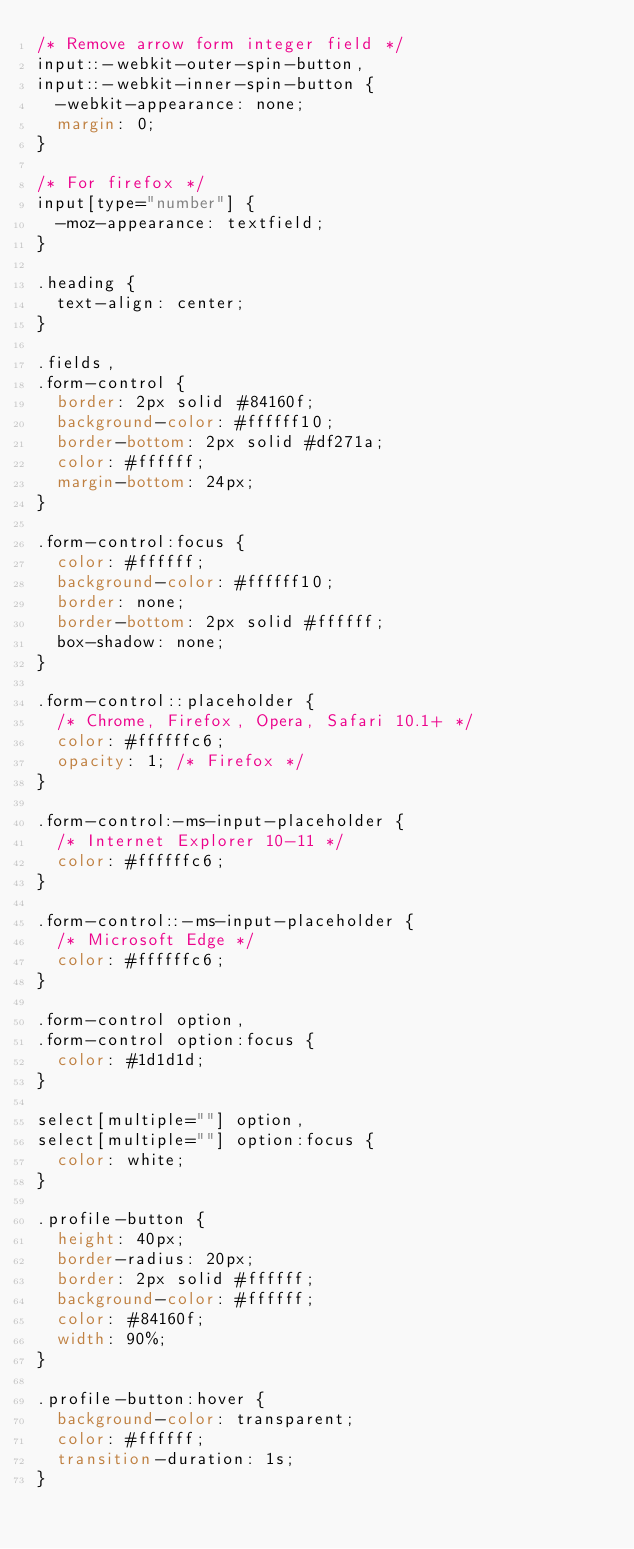<code> <loc_0><loc_0><loc_500><loc_500><_CSS_>/* Remove arrow form integer field */
input::-webkit-outer-spin-button,
input::-webkit-inner-spin-button {
  -webkit-appearance: none;
  margin: 0;
}

/* For firefox */
input[type="number"] {
  -moz-appearance: textfield;
}

.heading {
  text-align: center;
}

.fields,
.form-control {
  border: 2px solid #84160f;
  background-color: #ffffff10;
  border-bottom: 2px solid #df271a;
  color: #ffffff;
  margin-bottom: 24px;
}

.form-control:focus {
  color: #ffffff;
  background-color: #ffffff10;
  border: none;
  border-bottom: 2px solid #ffffff;
  box-shadow: none;
}

.form-control::placeholder {
  /* Chrome, Firefox, Opera, Safari 10.1+ */
  color: #ffffffc6;
  opacity: 1; /* Firefox */
}

.form-control:-ms-input-placeholder {
  /* Internet Explorer 10-11 */
  color: #ffffffc6;
}

.form-control::-ms-input-placeholder {
  /* Microsoft Edge */
  color: #ffffffc6;
}

.form-control option,
.form-control option:focus {
  color: #1d1d1d;
}

select[multiple=""] option,
select[multiple=""] option:focus {
  color: white;
}

.profile-button {
  height: 40px;
  border-radius: 20px;
  border: 2px solid #ffffff;
  background-color: #ffffff;
  color: #84160f;
  width: 90%;
}

.profile-button:hover {
  background-color: transparent;
  color: #ffffff;
  transition-duration: 1s;
}
</code> 